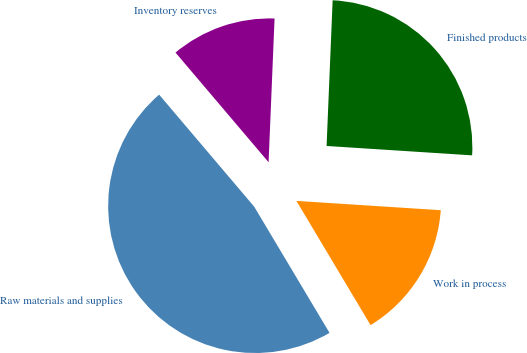<chart> <loc_0><loc_0><loc_500><loc_500><pie_chart><fcel>Raw materials and supplies<fcel>Work in process<fcel>Finished products<fcel>Inventory reserves<nl><fcel>47.36%<fcel>15.41%<fcel>25.36%<fcel>11.86%<nl></chart> 